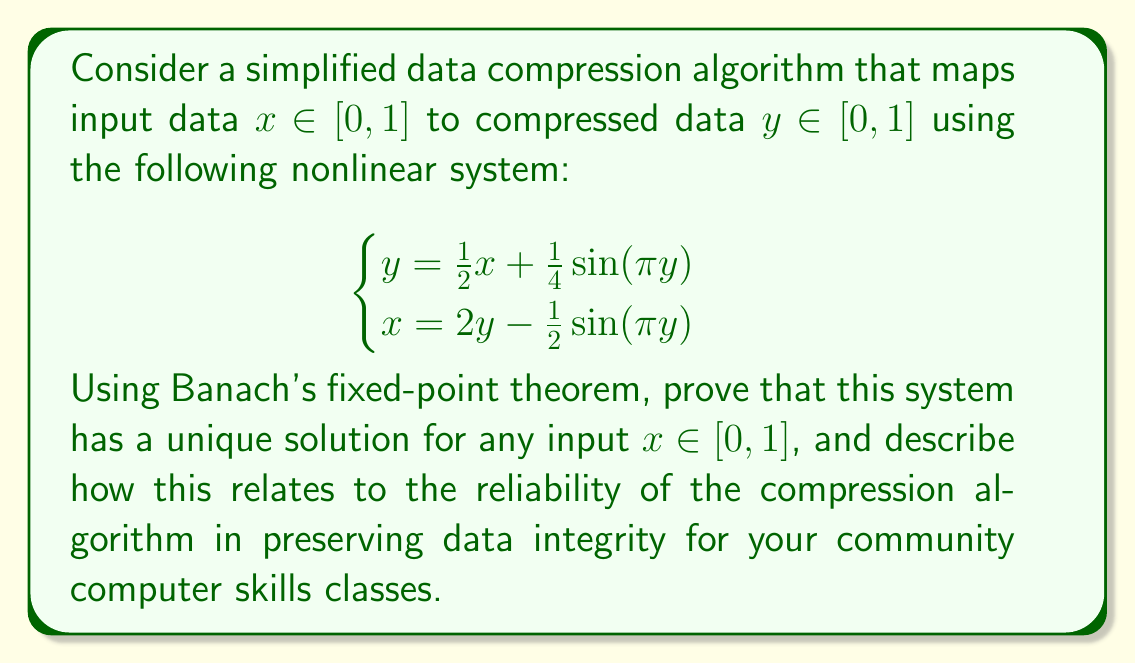Could you help me with this problem? To prove the existence of a unique solution using Banach's fixed-point theorem, we'll follow these steps:

1) First, we'll rewrite the system as a single equation in terms of y:
   $$y = \frac{1}{2}\left(2y - \frac{1}{2}\sin(\pi y)\right) + \frac{1}{4}\sin(\pi y)$$
   $$y = y - \frac{1}{4}\sin(\pi y) + \frac{1}{4}\sin(\pi y) = y$$

   This shows that any solution to the original system is a fixed point of the function $f(y) = \frac{1}{2}x + \frac{1}{4}\sin(\pi y)$.

2) Now, we'll prove that $f$ is a contraction mapping on $[0,1]$:
   $$|f(y_1) - f(y_2)| = \left|\frac{1}{4}\sin(\pi y_1) - \frac{1}{4}\sin(\pi y_2)\right|$$
   $$\leq \frac{1}{4}|\sin(\pi y_1) - \sin(\pi y_2)|$$
   $$\leq \frac{1}{4} \cdot \pi |y_1 - y_2|$$ (using the mean value theorem)
   $$= \frac{\pi}{4}|y_1 - y_2|$$

3) Since $\frac{\pi}{4} < 1$, $f$ is indeed a contraction mapping on $[0,1]$.

4) $[0,1]$ is a complete metric space.

5) For any $x \in [0,1]$, $f$ maps $[0,1]$ to itself:
   $$0 \leq \frac{1}{2}x + \frac{1}{4}\sin(\pi y) \leq \frac{1}{2} + \frac{1}{4} = \frac{3}{4} < 1$$

6) Therefore, by Banach's fixed-point theorem, $f$ has a unique fixed point in $[0,1]$ for any $x \in [0,1]$.

This result ensures that the compression algorithm has a unique, well-defined output for every input, guaranteeing data integrity. In the context of teaching computer skills to underserved communities, this means that the compression algorithm is reliable and consistent, which is crucial for maintaining the accuracy of digital information in various applications, from data storage to file sharing.
Answer: Unique solution exists by Banach's fixed-point theorem; ensures reliable data compression. 